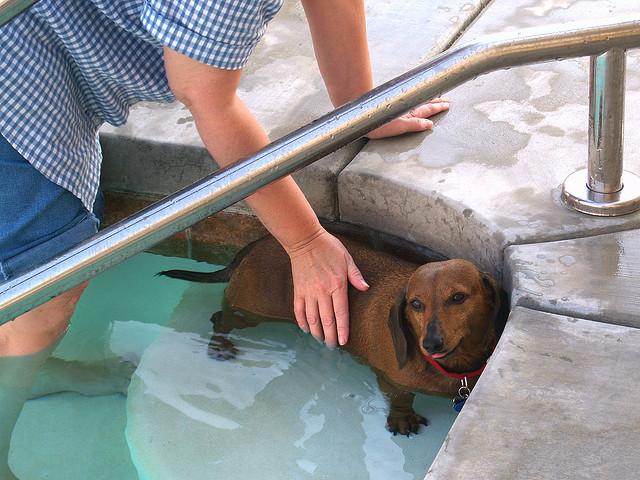Is this dog in a swimming pool?
Concise answer only. Yes. Is she petting the dog?
Answer briefly. Yes. What type of dog is this?
Answer briefly. Dachshund. 